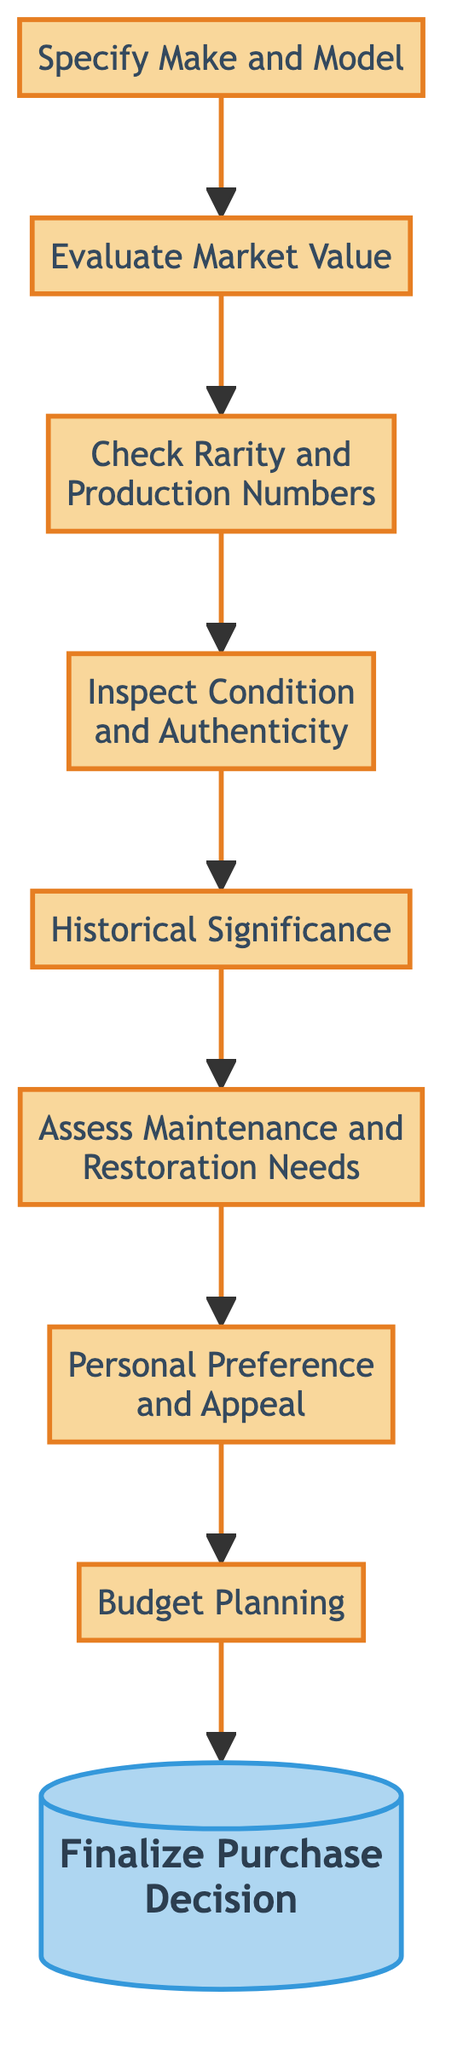What is the first step in the decision-making process? The first step, as indicated at the bottom of the diagram, is to "Specify Make and Model," which is the initial action required before proceeding further.
Answer: Specify Make and Model How many total steps are involved in the decision-making process? The flowchart outlines a total of nine steps, starting from specifying the make and model to finalizing the purchase decision.
Answer: 9 Which node directly precedes "Finalize Purchase Decision"? The node directly preceding "Finalize Purchase Decision" is "Budget Planning," indicating the decisions regarding finances must be finalized before making a purchase.
Answer: Budget Planning What is the purpose of the "Historical Significance" step? This step evaluates the car's historical relevance, considering factors such as racing heritage or famous previous owners, which adds depth to its value as a collectible.
Answer: Evaluate historical significance If "Inspect Condition and Authenticity" is favorable, which step follows? If the inspection yields positive results, the next step is "Historical Significance," as it flows sequentially from the inspection to evaluating historical importance.
Answer: Evaluate historical significance What type of decisions are made in the final step? The final step, "Finalize Purchase Decision," involves making a conclusive decision about acquiring the car based on the comprehensive assessment of all prior steps.
Answer: Final decision How does "Personal Preference and Appeal" influence the process? This step allows the collector to reflect on their subjective valuation of the car based on aesthetics, performance, and emotional connection, impacting the purchase decision.
Answer: Reflect on personal preference Which two steps are interconnected immediately above "Inspect Condition and Authenticity"? The steps "Check Rarity and Production Numbers" and "Evaluate Market Value" are interconnected with "Inspect Condition and Authenticity," indicating these factors must be considered before the inspection.
Answer: Evaluate market value, Check rarity and production numbers What is the last action in the diagram? The last action indicated in the flowchart is "Finalize Purchase Decision," representing the culmination of the entire assessment process.
Answer: Finalize Purchase Decision 